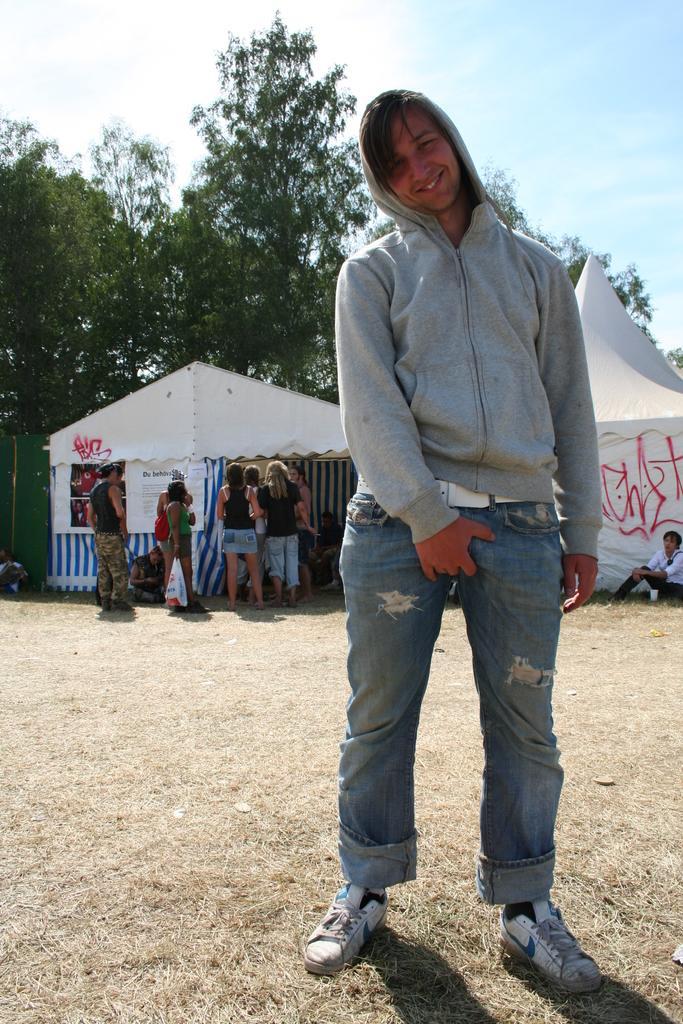In one or two sentences, can you explain what this image depicts? This picture is taken from the outside of the city. In this image, on the right side, we can see a man standing on the grass. In the background, we can see a group of people, tents. At the top, we can see a sky, at the bottom, we can see a grass. 